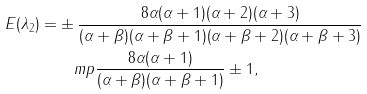Convert formula to latex. <formula><loc_0><loc_0><loc_500><loc_500>E ( \lambda _ { 2 } ) = & \pm \frac { 8 \alpha ( \alpha + 1 ) ( \alpha + 2 ) ( \alpha + 3 ) } { ( \alpha + \beta ) ( \alpha + \beta + 1 ) ( \alpha + \beta + 2 ) ( \alpha + \beta + 3 ) } \\ & \quad m p \frac { 8 \alpha ( \alpha + 1 ) } { ( \alpha + \beta ) ( \alpha + \beta + 1 ) } \pm 1 ,</formula> 